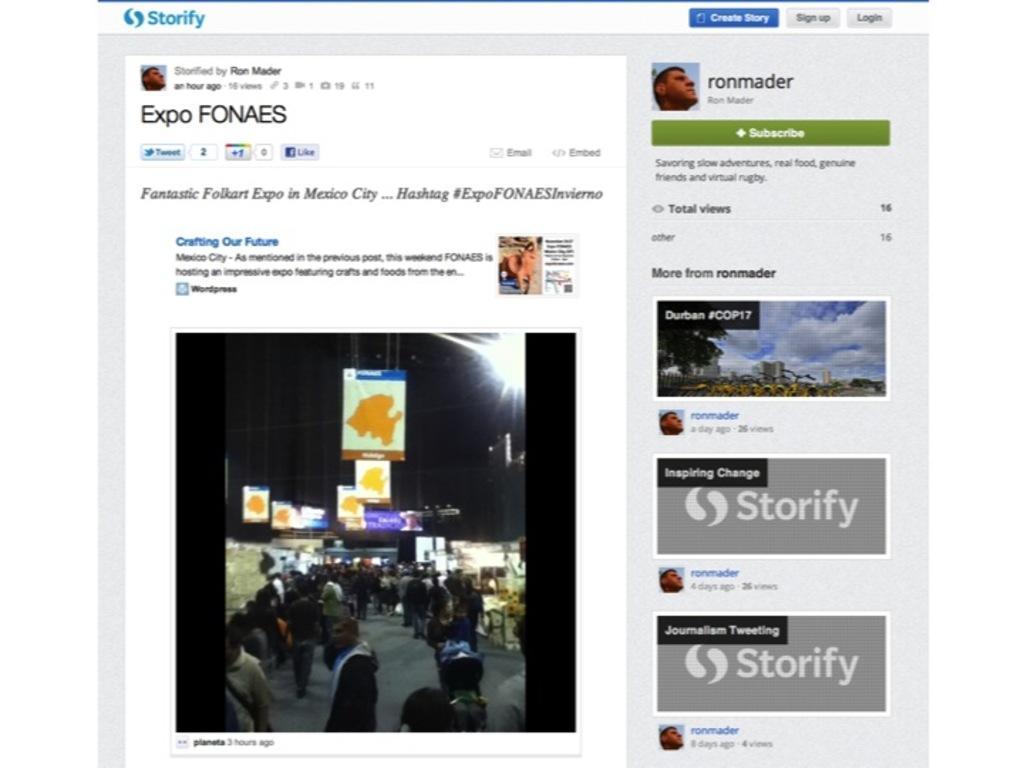How would you summarize this image in a sentence or two? In this image there is a web page with pictures, links and text. 